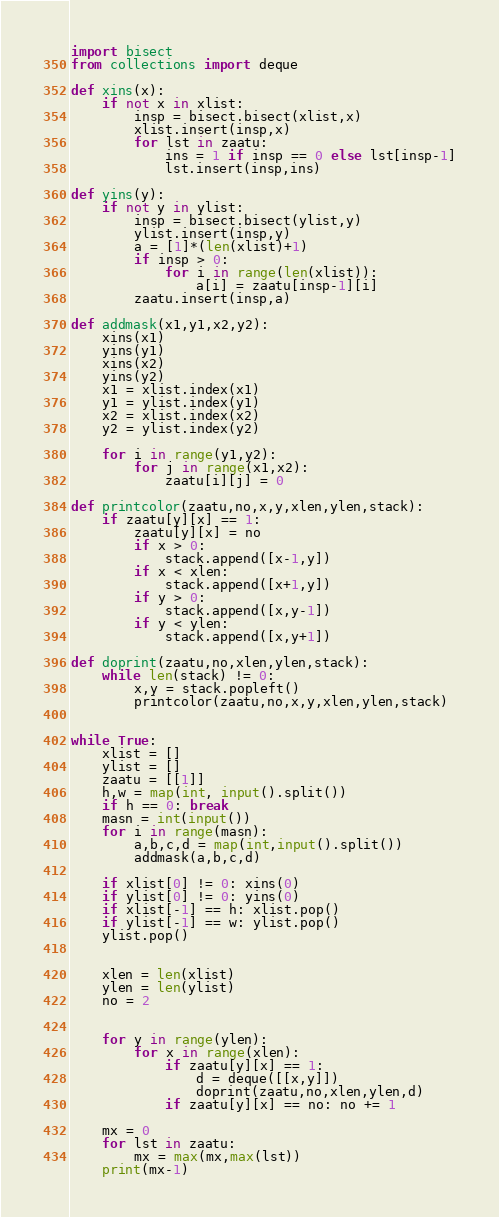<code> <loc_0><loc_0><loc_500><loc_500><_Python_>import bisect
from collections import deque

def xins(x):
    if not x in xlist:
        insp = bisect.bisect(xlist,x)
        xlist.insert(insp,x)
        for lst in zaatu:
            ins = 1 if insp == 0 else lst[insp-1]
            lst.insert(insp,ins)

def yins(y):
    if not y in ylist:
        insp = bisect.bisect(ylist,y)
        ylist.insert(insp,y)
        a = [1]*(len(xlist)+1)
        if insp > 0:
            for i in range(len(xlist)):
                a[i] = zaatu[insp-1][i]
        zaatu.insert(insp,a)

def addmask(x1,y1,x2,y2):
    xins(x1)
    yins(y1)
    xins(x2)
    yins(y2)
    x1 = xlist.index(x1)
    y1 = ylist.index(y1)
    x2 = xlist.index(x2)
    y2 = ylist.index(y2)

    for i in range(y1,y2):
        for j in range(x1,x2):
            zaatu[i][j] = 0

def printcolor(zaatu,no,x,y,xlen,ylen,stack):
    if zaatu[y][x] == 1:
        zaatu[y][x] = no
        if x > 0:
            stack.append([x-1,y])
        if x < xlen:
            stack.append([x+1,y])
        if y > 0:
            stack.append([x,y-1])
        if y < ylen:
            stack.append([x,y+1])

def doprint(zaatu,no,xlen,ylen,stack):
    while len(stack) != 0:
        x,y = stack.popleft()
        printcolor(zaatu,no,x,y,xlen,ylen,stack)


while True:
    xlist = []
    ylist = []
    zaatu = [[1]]
    h,w = map(int, input().split())
    if h == 0: break
    masn = int(input())
    for i in range(masn):
        a,b,c,d = map(int,input().split())
        addmask(a,b,c,d)

    if xlist[0] != 0: xins(0)
    if ylist[0] != 0: yins(0)
    if xlist[-1] == h: xlist.pop()
    if ylist[-1] == w: ylist.pop()
    ylist.pop()


    xlen = len(xlist)
    ylen = len(ylist)
    no = 2


    for y in range(ylen):
        for x in range(xlen):
            if zaatu[y][x] == 1:
                d = deque([[x,y]])
                doprint(zaatu,no,xlen,ylen,d)
            if zaatu[y][x] == no: no += 1

    mx = 0
    for lst in zaatu:
        mx = max(mx,max(lst))
    print(mx-1)</code> 